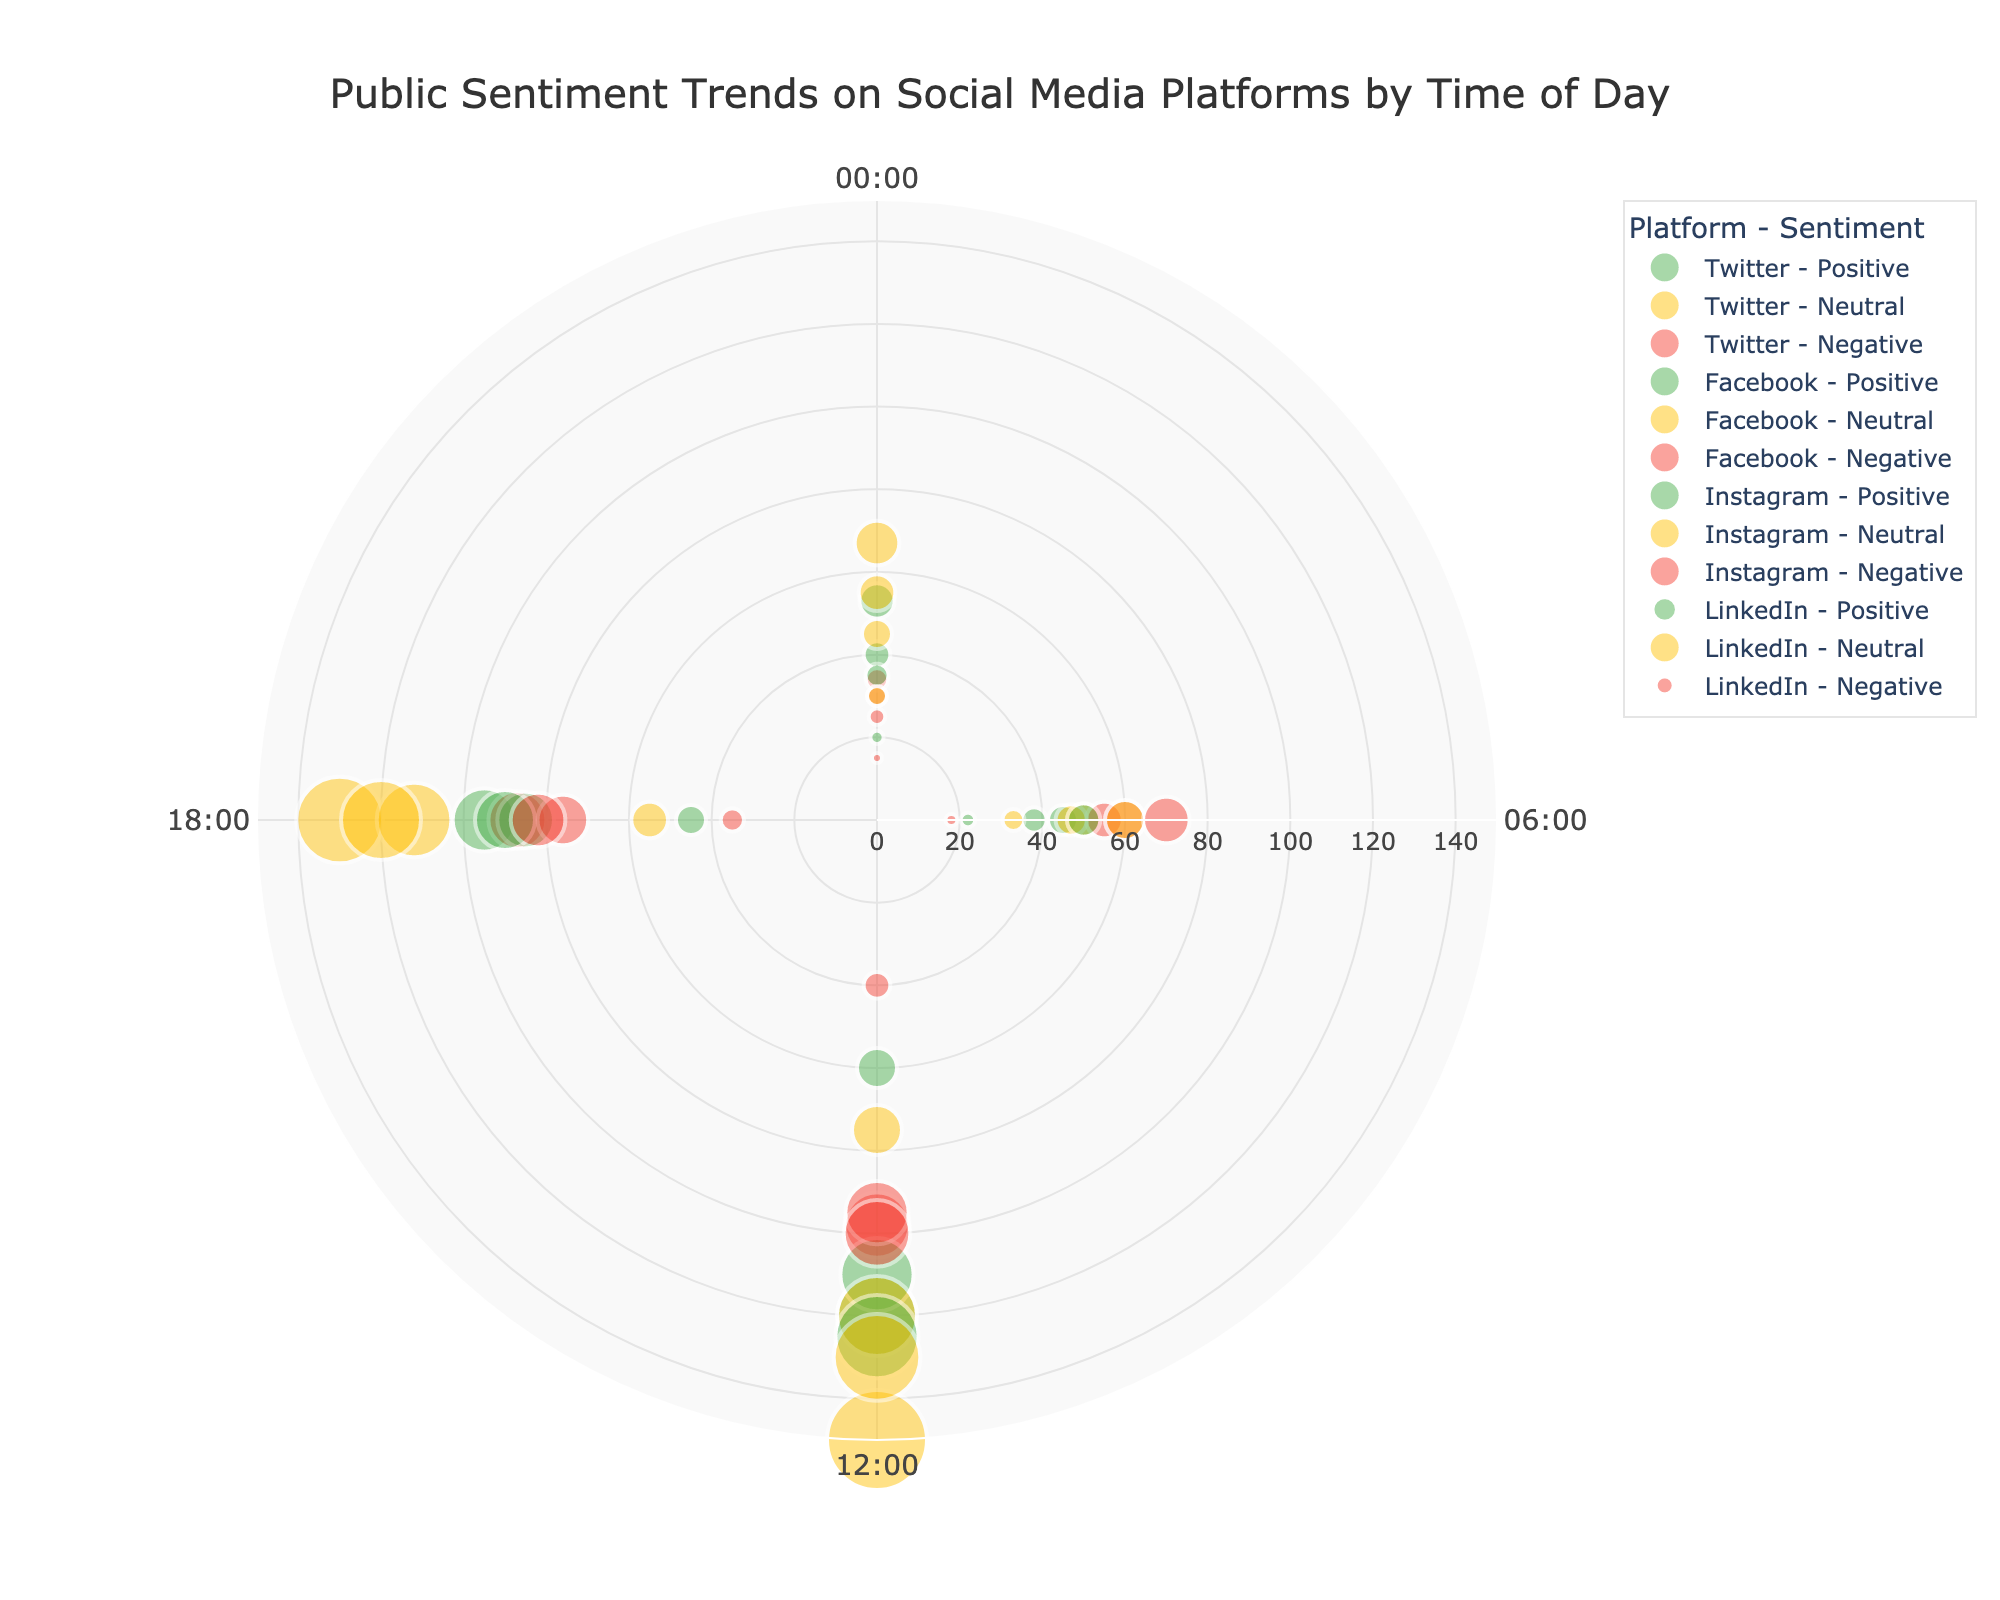Which platform has the highest positive sentiment at 12:00? Look for the '12:00' time mark and identify the highest radial distance among the green markers (Positive sentiment). Twitter has a count of 120, which is the highest.
Answer: Twitter What is the title of the figure? The title can be found at the top of the figure, and it reads "Public Sentiment Trends on Social Media Platforms by Time of Day".
Answer: Public Sentiment Trends on Social Media Platforms by Time of Day How many data points represent negative sentiment on Instagram at 18:00? Locate the red markers for Instagram at the '18:00' time mark. There is one red marker, which represents negative sentiment, with a count of 82.
Answer: 82 Which platform has the lowest neutral sentiment count at 00:00? Look for the '00:00' time mark and note the lowest radial distance among the yellow markers (Neutral sentiment). LinkedIn has the lowest count of 30.
Answer: LinkedIn For Facebook, how does the positive sentiment count at 12:00 compare to 18:00? Compare the radial distances of the green markers (Positive sentiment) for Facebook at '12:00' and '18:00'. At '12:00', the count is 110, while at '18:00', the count is 85. Therefore, the count at '12:00' is higher.
Answer: 12:00 is higher What is the total count of neutral sentiments recorded at 06:00 across all platforms? Sum the radial distances of the yellow markers (Neutral sentiment) for all platforms at '06:00'. Twitter: 50, Facebook: 47, Instagram: 60, LinkedIn: 33. Total = 50 + 47 + 60 + 33 = 190.
Answer: 190 Which time of day has the highest negative sentiment for all platforms combined? Sum the radial distances of the red markers (Negative sentiment) for each time of day and identify the highest total. '00:00': 34 + 30 + 25 + 15 = 104, '06:00': 55 + 60 + 70 + 18 = 203, '12:00': 98 + 95 + 100 + 40 = 333, '18:00': 87 + 76 + 82 + 35 = 280. '12:00' has the highest total negative sentiment.
Answer: 12:00 How does Twitter's sentiment distribution at 12:00 compare to Facebook's at the same time? Compare the radial distances of all three markers (Positive, Neutral, and Negative) for Twitter and Facebook at '12:00'. Twitter: Positive: 120, Neutral: 150, Negative: 98. Facebook: Positive: 110, Neutral: 120, Negative: 95. Twitter has higher counts in Positive and Neutral sentiments, while both platforms have similar negative sentiment counts.
Answer: Twitter is generally higher Which sentiment has the smallest marker size for LinkedIn at 06:00? Check the radial distances of the markers (Positive, Neutral, and Negative) for LinkedIn at '06:00'. Positive sentiment has the smallest marker size with a count of 22.
Answer: Positive What is the color associated with neutral sentiment in the figure? Identify the color of the markers corresponding to Neutral sentiment. The yellow markers indicate neutral sentiment.
Answer: Yellow 